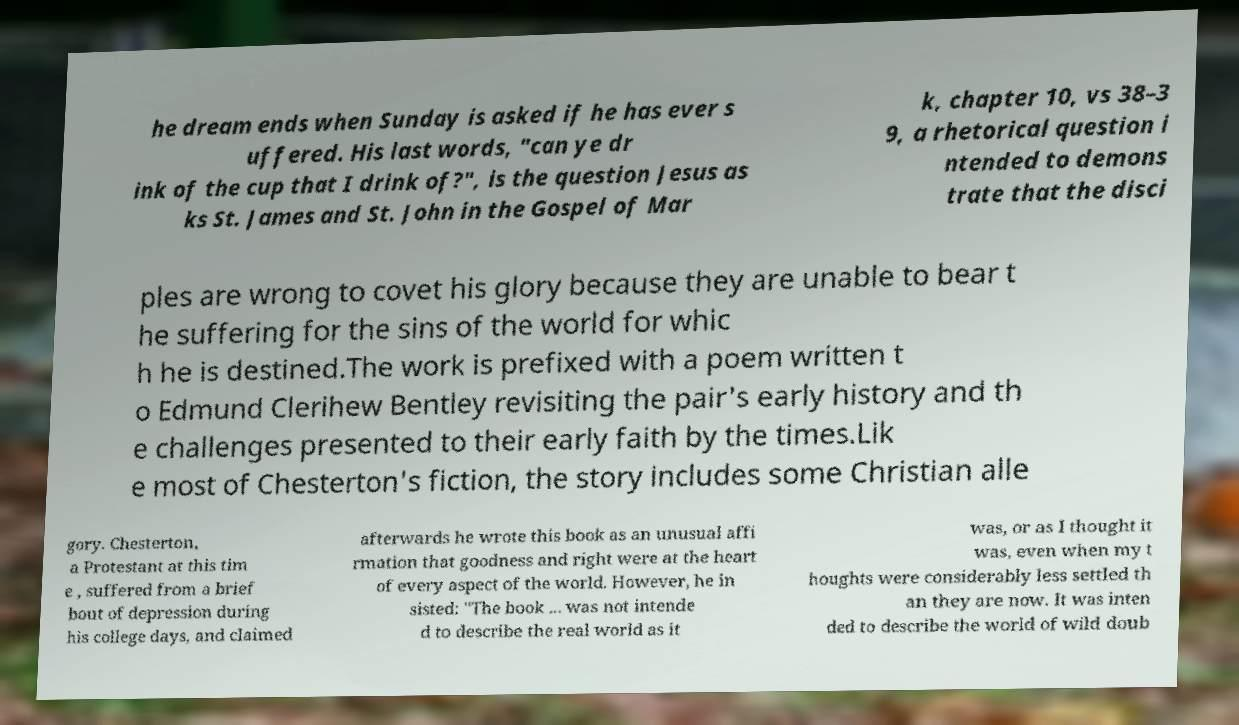Please read and relay the text visible in this image. What does it say? he dream ends when Sunday is asked if he has ever s uffered. His last words, "can ye dr ink of the cup that I drink of?", is the question Jesus as ks St. James and St. John in the Gospel of Mar k, chapter 10, vs 38–3 9, a rhetorical question i ntended to demons trate that the disci ples are wrong to covet his glory because they are unable to bear t he suffering for the sins of the world for whic h he is destined.The work is prefixed with a poem written t o Edmund Clerihew Bentley revisiting the pair's early history and th e challenges presented to their early faith by the times.Lik e most of Chesterton's fiction, the story includes some Christian alle gory. Chesterton, a Protestant at this tim e , suffered from a brief bout of depression during his college days, and claimed afterwards he wrote this book as an unusual affi rmation that goodness and right were at the heart of every aspect of the world. However, he in sisted: "The book ... was not intende d to describe the real world as it was, or as I thought it was, even when my t houghts were considerably less settled th an they are now. It was inten ded to describe the world of wild doub 